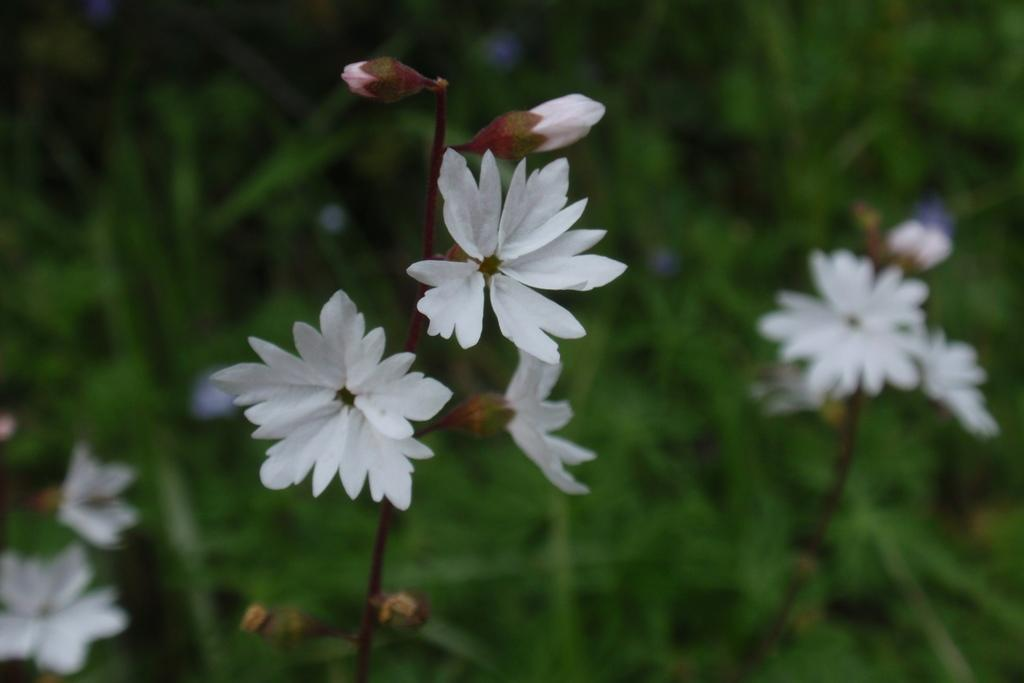What can be seen on the plants in the image? There are flowers on the plants in the image. What stage of growth can be observed on the plants in the image? There are buds on the plants in the image. How many friends can be seen playing with the horn in the image? There are no friends or horns present in the image; it features plants with flowers and buds. 